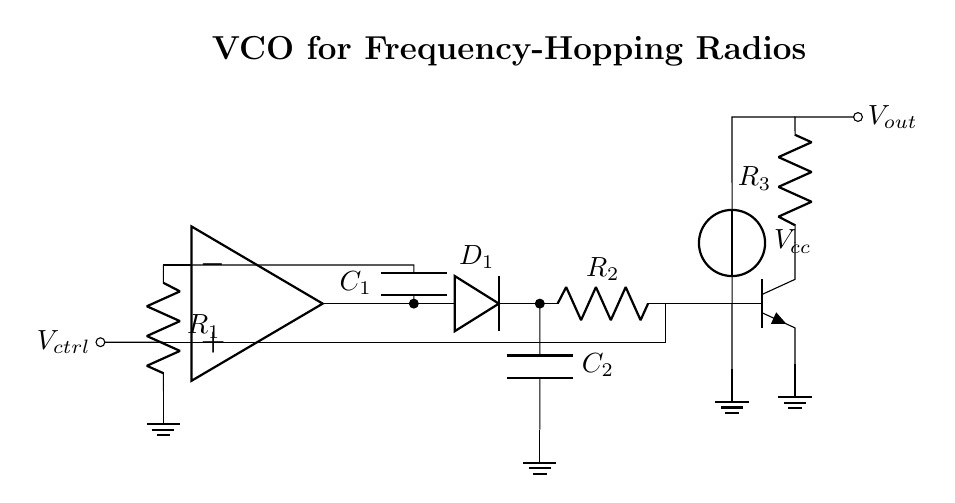what component controls the output frequency? The component that controls the output frequency is the varactor diode, which varies its capacitance with the control voltage. This variable capacitance directly affects the oscillation frequency of the VCO.
Answer: varactor diode what is the value of the resistor connected to the inverting input of the op-amp? The value of the resistor connected to the inverting input of the op-amp is denoted as R1. This resistor sets the gain and influences the stability of the oscillator circuit.
Answer: R1 how many capacitors are present in this circuit? The circuit contains two capacitors: C1 and C2. C1 is part of the feedback loop, while C2 is connected to the varactor diode as part of the tuning process.
Answer: two what is the role of the output buffer transistor? The output buffer transistor serves to isolate the oscillator circuit from the load, ensuring that the oscillations are not affected by the connected load, and also helps to drive higher currents if needed.
Answer: isolation which component provides the supply voltage? The supply voltage is provided by the voltage source labeled Vcc. This component is essential for powering the entire circuit, including the op-amp and the buffer transistor.
Answer: Vcc what kind of oscillator is represented in the circuit? The oscillator represented in the circuit is a voltage-controlled oscillator (VCO). Its frequency is modulated by varying the control voltage applied to the varactor diode.
Answer: voltage-controlled oscillator what is the purpose of the feedback resistor R2? The purpose of feedback resistor R2 is to create a feedback loop that stabilizes the oscillation process, helping to determine the gain and characteristics of the oscillator.
Answer: stabilization 